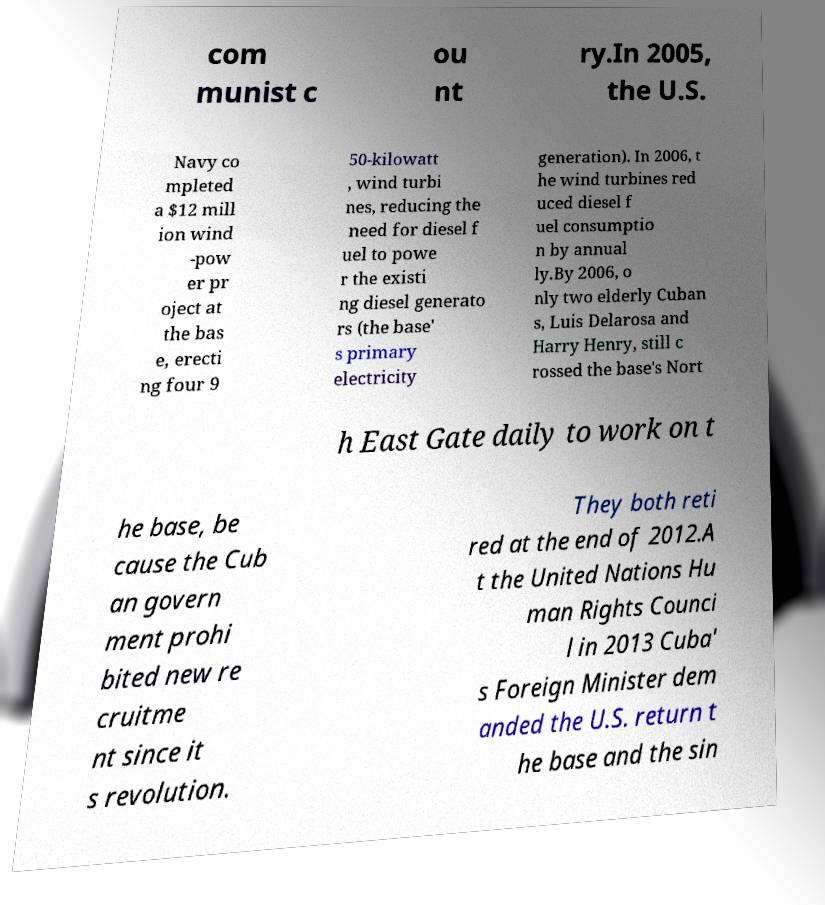I need the written content from this picture converted into text. Can you do that? com munist c ou nt ry.In 2005, the U.S. Navy co mpleted a $12 mill ion wind -pow er pr oject at the bas e, erecti ng four 9 50-kilowatt , wind turbi nes, reducing the need for diesel f uel to powe r the existi ng diesel generato rs (the base' s primary electricity generation). In 2006, t he wind turbines red uced diesel f uel consumptio n by annual ly.By 2006, o nly two elderly Cuban s, Luis Delarosa and Harry Henry, still c rossed the base's Nort h East Gate daily to work on t he base, be cause the Cub an govern ment prohi bited new re cruitme nt since it s revolution. They both reti red at the end of 2012.A t the United Nations Hu man Rights Counci l in 2013 Cuba' s Foreign Minister dem anded the U.S. return t he base and the sin 